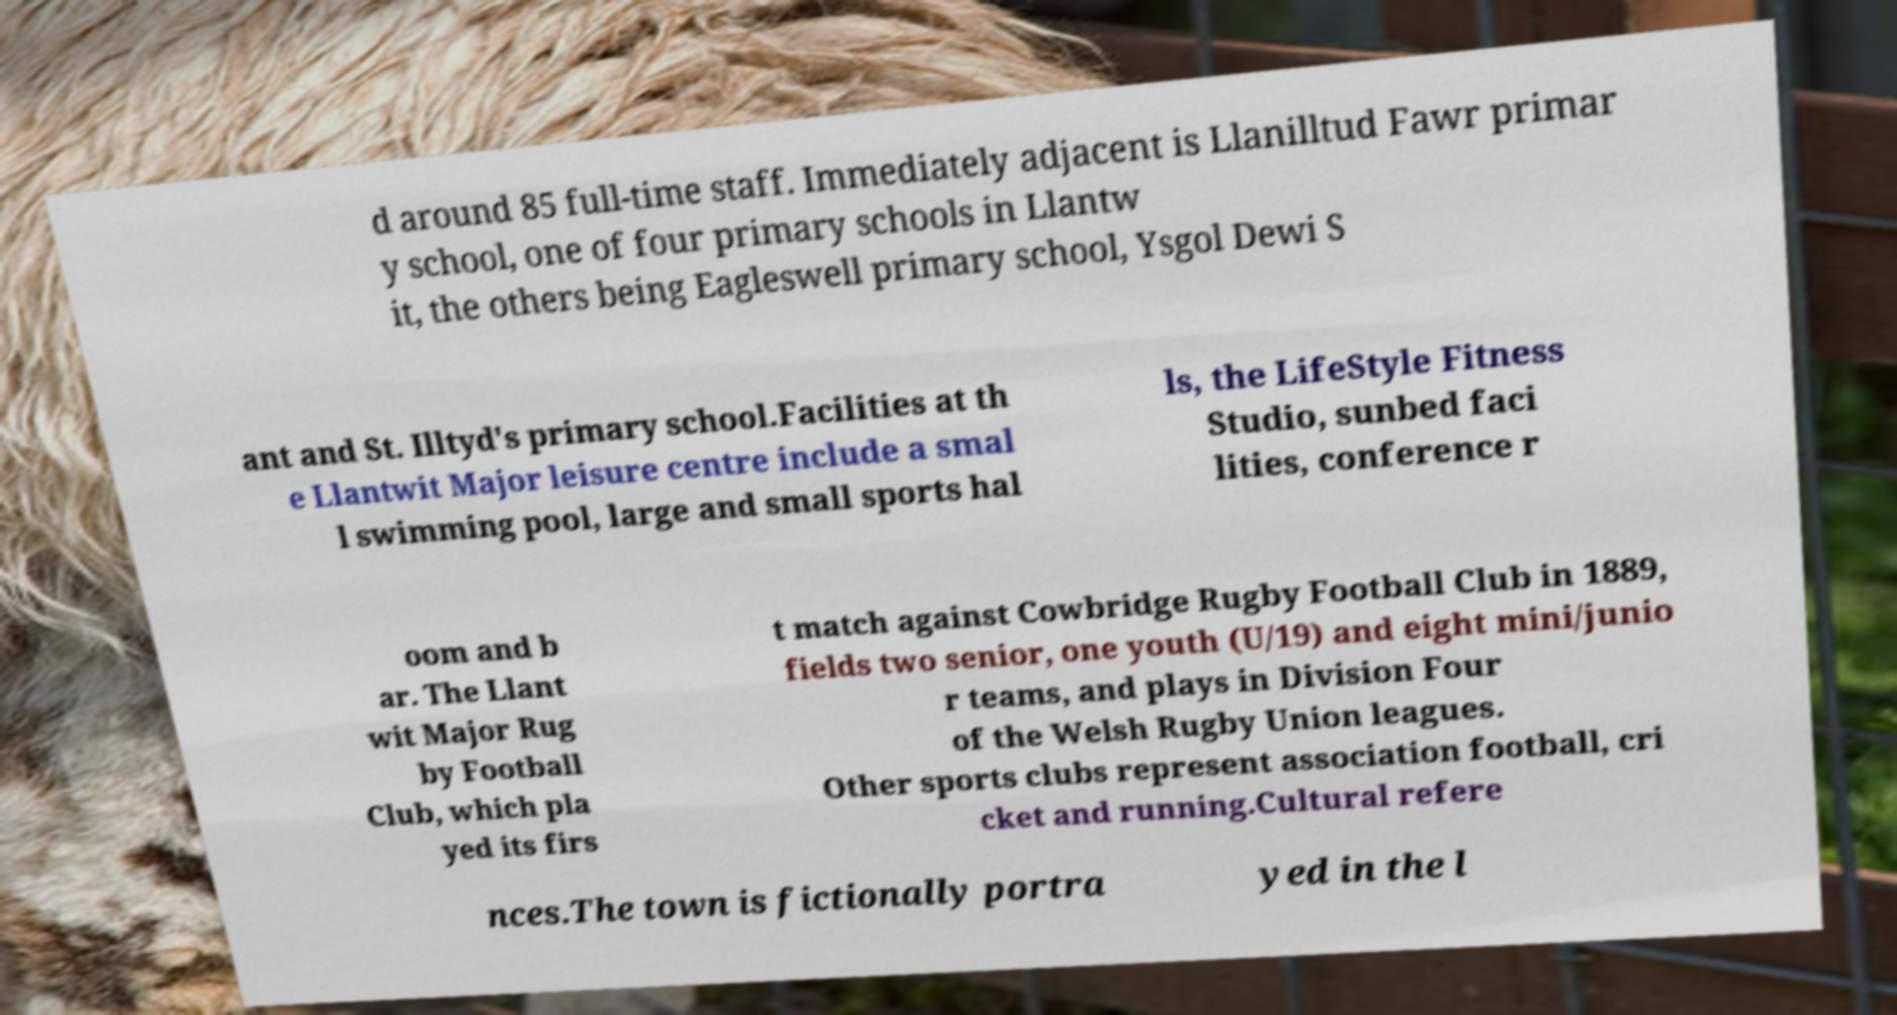Could you extract and type out the text from this image? d around 85 full-time staff. Immediately adjacent is Llanilltud Fawr primar y school, one of four primary schools in Llantw it, the others being Eagleswell primary school, Ysgol Dewi S ant and St. Illtyd's primary school.Facilities at th e Llantwit Major leisure centre include a smal l swimming pool, large and small sports hal ls, the LifeStyle Fitness Studio, sunbed faci lities, conference r oom and b ar. The Llant wit Major Rug by Football Club, which pla yed its firs t match against Cowbridge Rugby Football Club in 1889, fields two senior, one youth (U/19) and eight mini/junio r teams, and plays in Division Four of the Welsh Rugby Union leagues. Other sports clubs represent association football, cri cket and running.Cultural refere nces.The town is fictionally portra yed in the l 